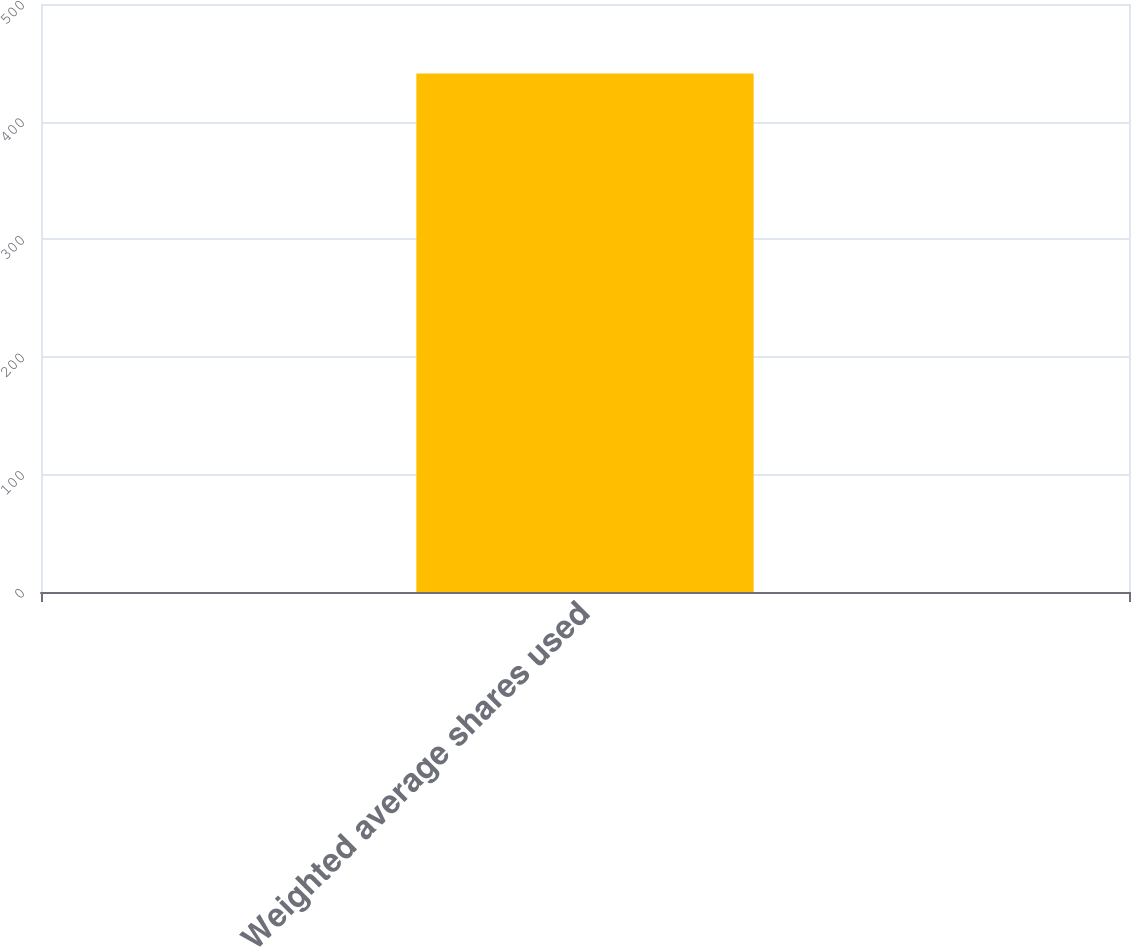Convert chart to OTSL. <chart><loc_0><loc_0><loc_500><loc_500><bar_chart><fcel>Weighted average shares used<nl><fcel>441<nl></chart> 